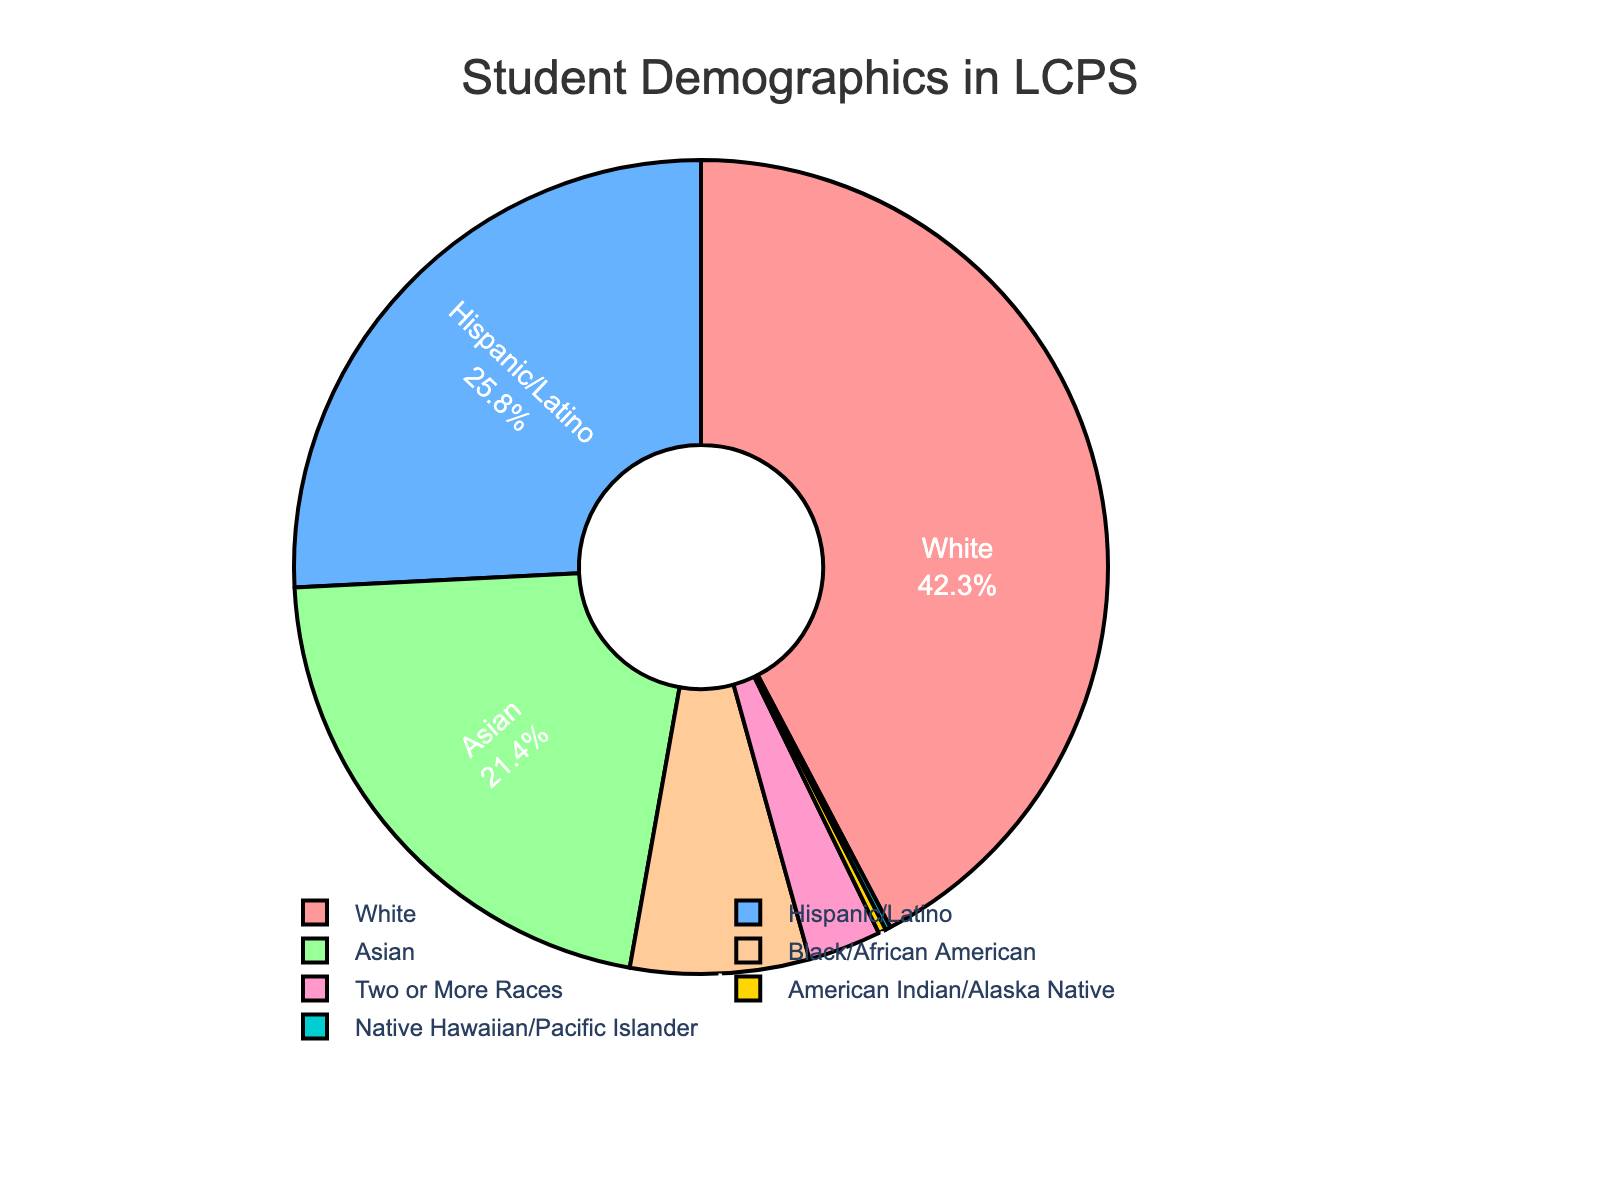What's the percentage of Hispanic/Latino students? The pie chart shows that the segment labeled Hispanic/Latino is 25.8%.
Answer: 25.8% Which group has the smallest representation? By observing the sections of the pie chart, the smallest segment is labeled Native Hawaiian/Pacific Islander, which corresponds to 0.2%.
Answer: Native Hawaiian/Pacific Islander Is the combined percentage of Asian and Black/African American students greater than 25%? First, we obtain the percentage of Asian students which is 21.4% and Black/African American students which is 7.1%. The sum is 21.4% + 7.1% = 28.5%, which is greater than 25%.
Answer: Yes Are there more White students or Hispanic/Latino students in LCPS? Comparing the percentages, White students are 42.3% and Hispanic/Latino students are 25.8%. Since 42.3% is greater than 25.8%, there are more White students.
Answer: White students What is the percentage difference between White and Asian students? The percentage of White students is 42.3%, while the percentage of Asian students is 21.4%. The difference is 42.3% - 21.4% = 20.9%.
Answer: 20.9% What percentage of students identifies as either Two or More Races or American Indian/Alaska Native? Adding the percentages of Two or More Races (2.9%) and American Indian/Alaska Native (0.3%), the total is 2.9% + 0.3% = 3.2%.
Answer: 3.2% By how much does the percentage of Black/African American students exceed the combined percentage of American Indian/Alaska Native and Native Hawaiian/Pacific Islander students? The percentage of Black/African American students is 7.1%. The combined percentage of American Indian/Alaska Native and Native Hawaiian/Pacific Islander students is 0.3% + 0.2% = 0.5%. The difference is 7.1% - 0.5% = 6.6%.
Answer: 6.6% Which two racial/ethnic groups have percentages that sum closest to 50%? By examining the segments, the percentages for White (42.3%) and Hispanic/Latino (25.8%) sum to 68.1%, which is far from 50%. Checking White (42.3%) and Asian (21.4%), they sum to 63.7%. However, Hispanic/Latino (25.8%) and Black/African American (7.1%) sum to 32.9%, which is not close. White (42.3%) and Two or More Races (2.9%) sum to 45.2%, the closest to 50%.
Answer: White and Two or More Races Which racial/ethnic groups make up less than 5% of the total student population in LCPS? The pie chart shows the segments for Two or More Races (2.9%), American Indian/Alaska Native (0.3%), and Native Hawaiian/Pacific Islander (0.2%) as making up less than 5% each.
Answer: Two or More Races, American Indian/Alaska Native, Native Hawaiian/Pacific Islander 